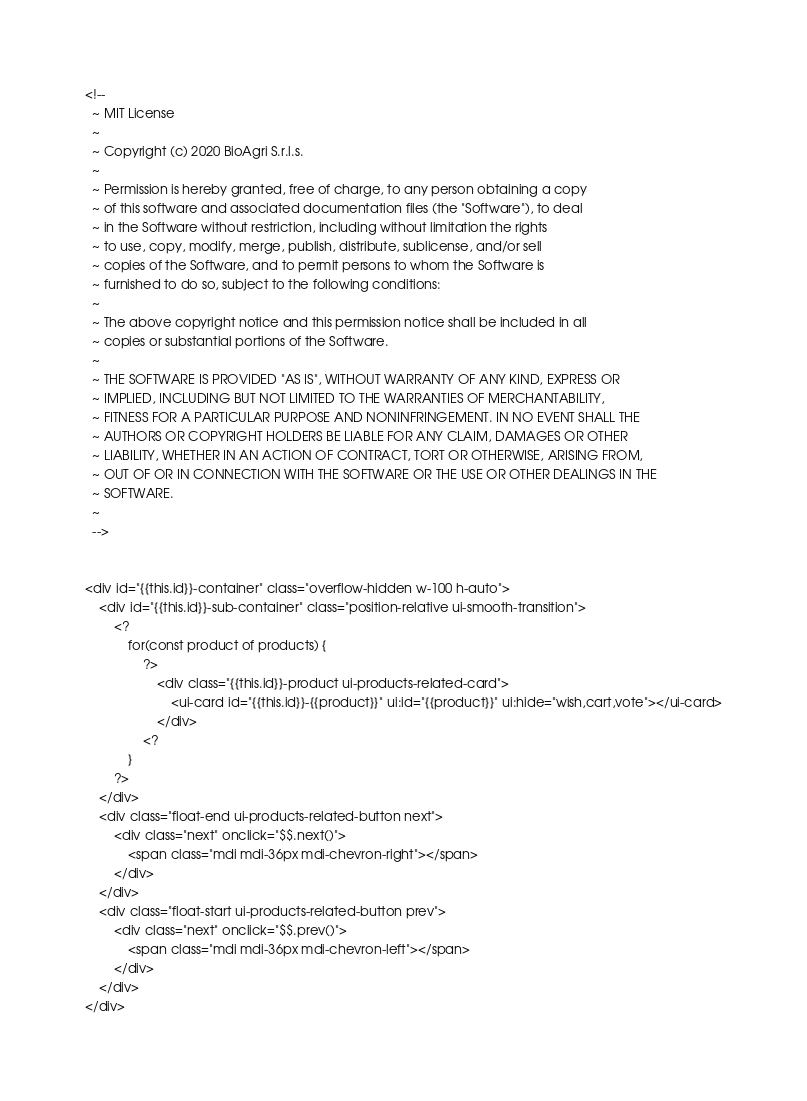Convert code to text. <code><loc_0><loc_0><loc_500><loc_500><_XML_><!--
  ~ MIT License
  ~
  ~ Copyright (c) 2020 BioAgri S.r.l.s.
  ~
  ~ Permission is hereby granted, free of charge, to any person obtaining a copy
  ~ of this software and associated documentation files (the "Software"), to deal
  ~ in the Software without restriction, including without limitation the rights
  ~ to use, copy, modify, merge, publish, distribute, sublicense, and/or sell
  ~ copies of the Software, and to permit persons to whom the Software is
  ~ furnished to do so, subject to the following conditions:
  ~
  ~ The above copyright notice and this permission notice shall be included in all
  ~ copies or substantial portions of the Software.
  ~
  ~ THE SOFTWARE IS PROVIDED "AS IS", WITHOUT WARRANTY OF ANY KIND, EXPRESS OR
  ~ IMPLIED, INCLUDING BUT NOT LIMITED TO THE WARRANTIES OF MERCHANTABILITY,
  ~ FITNESS FOR A PARTICULAR PURPOSE AND NONINFRINGEMENT. IN NO EVENT SHALL THE
  ~ AUTHORS OR COPYRIGHT HOLDERS BE LIABLE FOR ANY CLAIM, DAMAGES OR OTHER
  ~ LIABILITY, WHETHER IN AN ACTION OF CONTRACT, TORT OR OTHERWISE, ARISING FROM,
  ~ OUT OF OR IN CONNECTION WITH THE SOFTWARE OR THE USE OR OTHER DEALINGS IN THE
  ~ SOFTWARE.
  ~
  -->


<div id="{{this.id}}-container" class="overflow-hidden w-100 h-auto">
    <div id="{{this.id}}-sub-container" class="position-relative ui-smooth-transition">
        <?
            for(const product of products) {
                ?>
                    <div class="{{this.id}}-product ui-products-related-card">
                        <ui-card id="{{this.id}}-{{product}}" ui:id="{{product}}" ui:hide="wish,cart,vote"></ui-card>
                    </div>
                <?
            }
        ?>
    </div>
    <div class="float-end ui-products-related-button next">
        <div class="next" onclick="$$.next()">
            <span class="mdi mdi-36px mdi-chevron-right"></span>
        </div>
    </div>
    <div class="float-start ui-products-related-button prev">
        <div class="next" onclick="$$.prev()">
            <span class="mdi mdi-36px mdi-chevron-left"></span>
        </div>
    </div>
</div>


</code> 